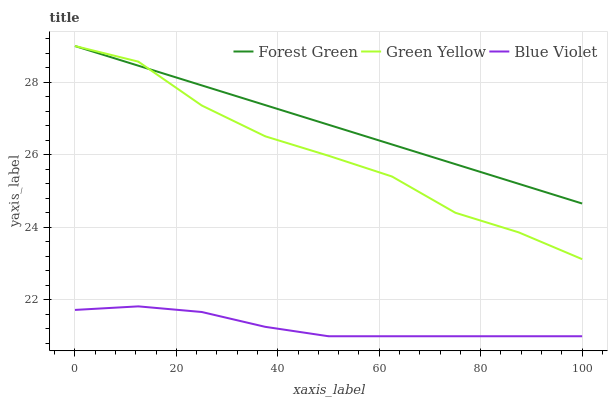Does Blue Violet have the minimum area under the curve?
Answer yes or no. Yes. Does Forest Green have the maximum area under the curve?
Answer yes or no. Yes. Does Green Yellow have the minimum area under the curve?
Answer yes or no. No. Does Green Yellow have the maximum area under the curve?
Answer yes or no. No. Is Forest Green the smoothest?
Answer yes or no. Yes. Is Green Yellow the roughest?
Answer yes or no. Yes. Is Blue Violet the smoothest?
Answer yes or no. No. Is Blue Violet the roughest?
Answer yes or no. No. Does Green Yellow have the lowest value?
Answer yes or no. No. Does Blue Violet have the highest value?
Answer yes or no. No. Is Blue Violet less than Green Yellow?
Answer yes or no. Yes. Is Green Yellow greater than Blue Violet?
Answer yes or no. Yes. Does Blue Violet intersect Green Yellow?
Answer yes or no. No. 